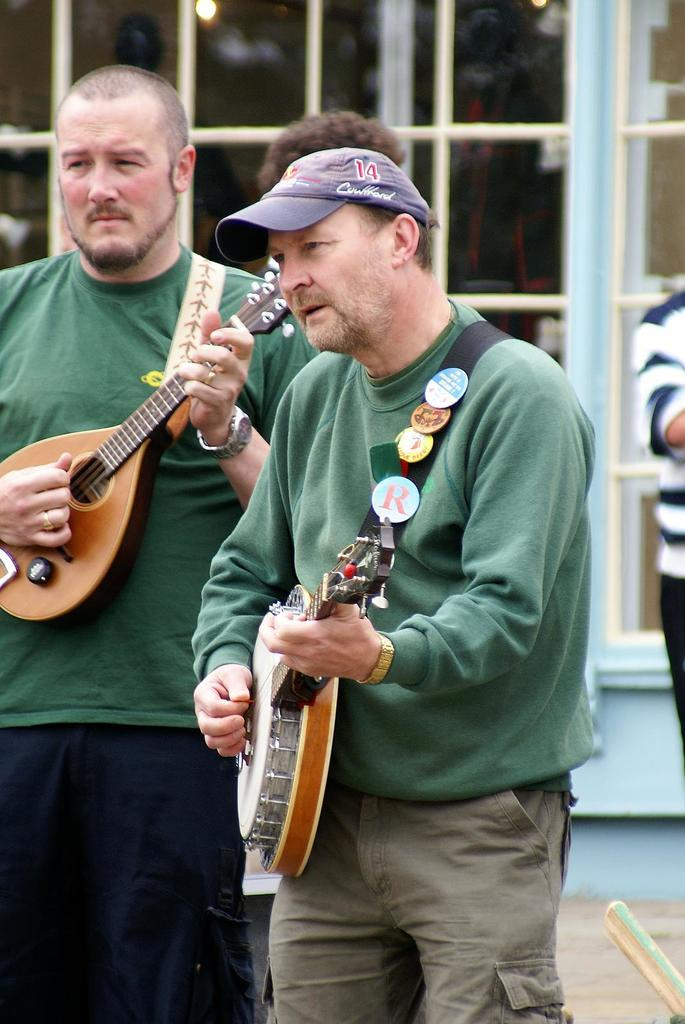How many people are in the image? There are two persons in the image. What are the people wearing? Both persons are wearing green t-shirts. What activity are the people engaged in? The persons are playing guitar. Can you describe any additional clothing items worn by one of the persons? One man is wearing a blue cap. What can be seen in the background of the image? There are other persons in the background and a glass window. How many beggars are visible in the image? There are no beggars present in the image. What type of stocking is being used by one of the persons in the image? There is no stocking visible in the image; both persons are wearing green t-shirts and playing guitar. 